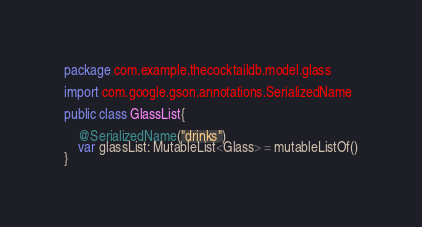<code> <loc_0><loc_0><loc_500><loc_500><_Kotlin_>package com.example.thecocktaildb.model.glass

import com.google.gson.annotations.SerializedName

public class GlassList{

    @SerializedName("drinks")
    var glassList: MutableList<Glass> = mutableListOf()
}</code> 